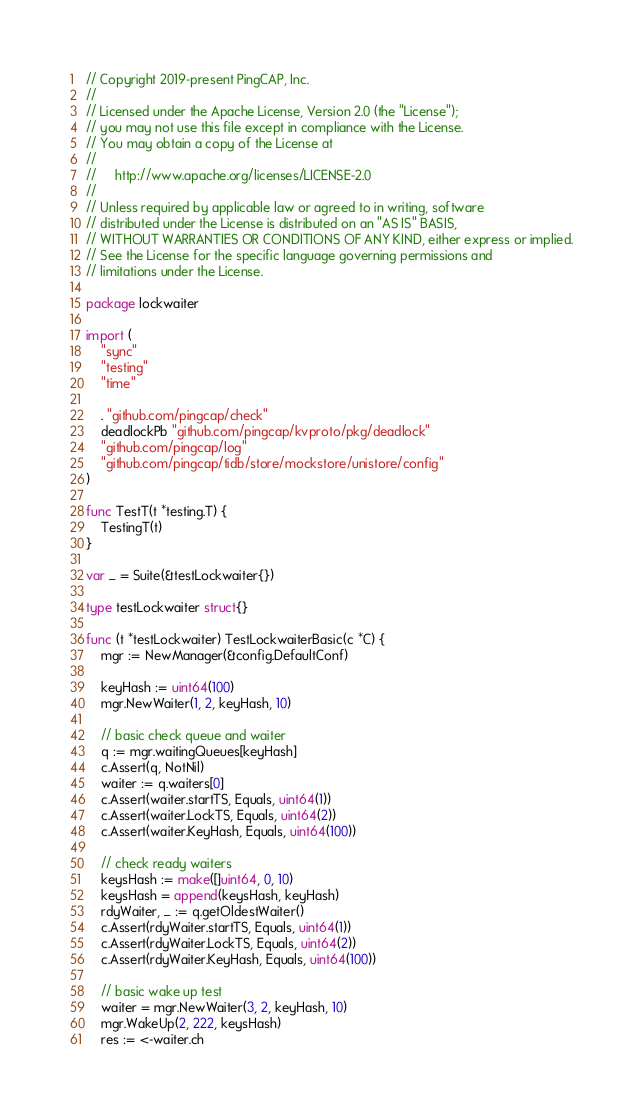Convert code to text. <code><loc_0><loc_0><loc_500><loc_500><_Go_>// Copyright 2019-present PingCAP, Inc.
//
// Licensed under the Apache License, Version 2.0 (the "License");
// you may not use this file except in compliance with the License.
// You may obtain a copy of the License at
//
//     http://www.apache.org/licenses/LICENSE-2.0
//
// Unless required by applicable law or agreed to in writing, software
// distributed under the License is distributed on an "AS IS" BASIS,
// WITHOUT WARRANTIES OR CONDITIONS OF ANY KIND, either express or implied.
// See the License for the specific language governing permissions and
// limitations under the License.

package lockwaiter

import (
	"sync"
	"testing"
	"time"

	. "github.com/pingcap/check"
	deadlockPb "github.com/pingcap/kvproto/pkg/deadlock"
	"github.com/pingcap/log"
	"github.com/pingcap/tidb/store/mockstore/unistore/config"
)

func TestT(t *testing.T) {
	TestingT(t)
}

var _ = Suite(&testLockwaiter{})

type testLockwaiter struct{}

func (t *testLockwaiter) TestLockwaiterBasic(c *C) {
	mgr := NewManager(&config.DefaultConf)

	keyHash := uint64(100)
	mgr.NewWaiter(1, 2, keyHash, 10)

	// basic check queue and waiter
	q := mgr.waitingQueues[keyHash]
	c.Assert(q, NotNil)
	waiter := q.waiters[0]
	c.Assert(waiter.startTS, Equals, uint64(1))
	c.Assert(waiter.LockTS, Equals, uint64(2))
	c.Assert(waiter.KeyHash, Equals, uint64(100))

	// check ready waiters
	keysHash := make([]uint64, 0, 10)
	keysHash = append(keysHash, keyHash)
	rdyWaiter, _ := q.getOldestWaiter()
	c.Assert(rdyWaiter.startTS, Equals, uint64(1))
	c.Assert(rdyWaiter.LockTS, Equals, uint64(2))
	c.Assert(rdyWaiter.KeyHash, Equals, uint64(100))

	// basic wake up test
	waiter = mgr.NewWaiter(3, 2, keyHash, 10)
	mgr.WakeUp(2, 222, keysHash)
	res := <-waiter.ch</code> 